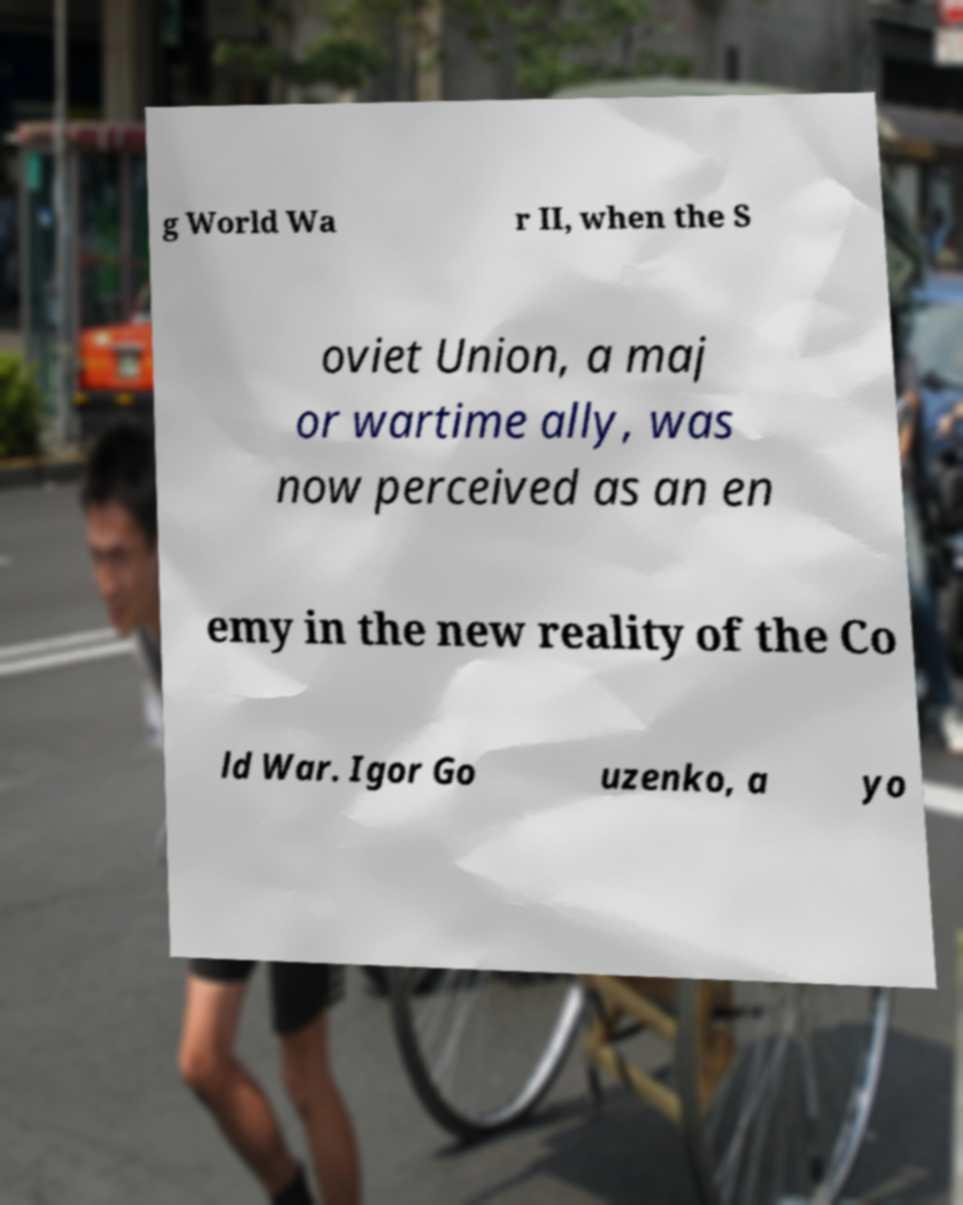Could you extract and type out the text from this image? g World Wa r II, when the S oviet Union, a maj or wartime ally, was now perceived as an en emy in the new reality of the Co ld War. Igor Go uzenko, a yo 